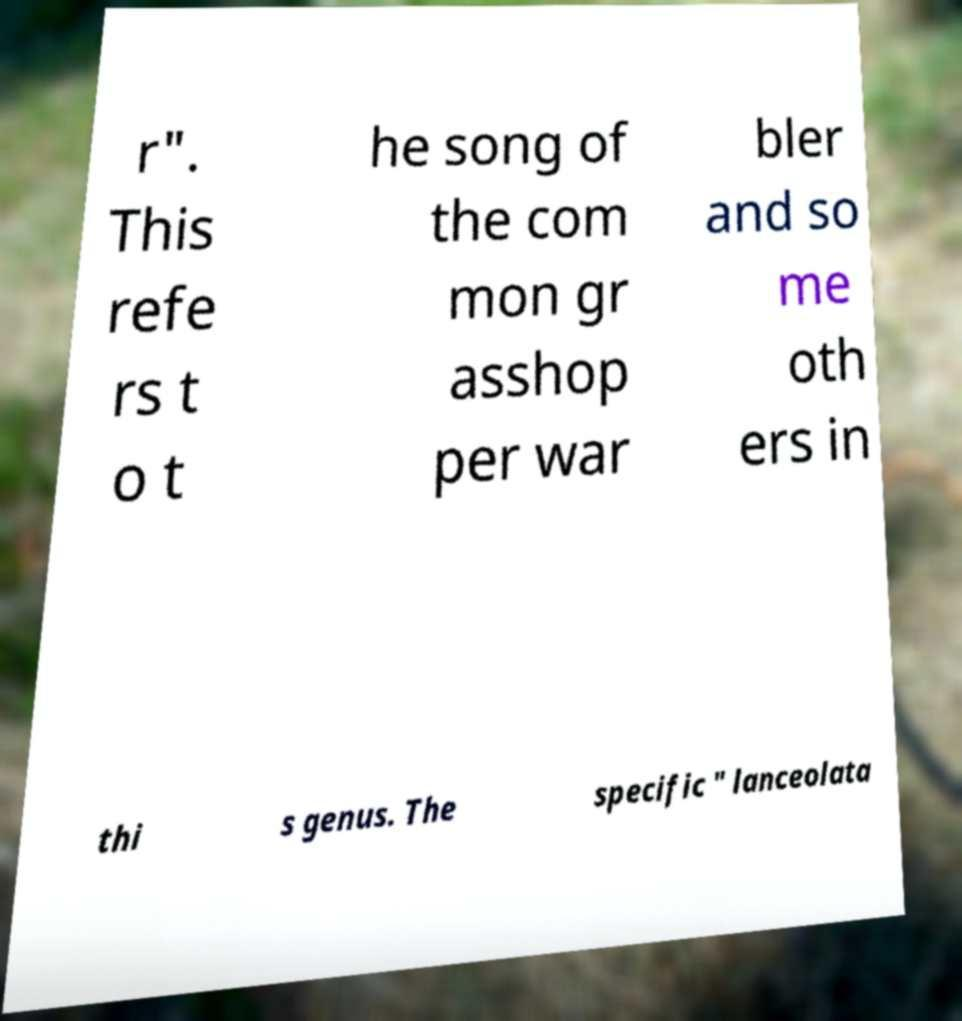Please read and relay the text visible in this image. What does it say? r". This refe rs t o t he song of the com mon gr asshop per war bler and so me oth ers in thi s genus. The specific " lanceolata 